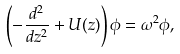<formula> <loc_0><loc_0><loc_500><loc_500>\left ( - \frac { d ^ { 2 } } { d z ^ { 2 } } + U ( z ) \right ) \phi = \omega ^ { 2 } \phi ,</formula> 